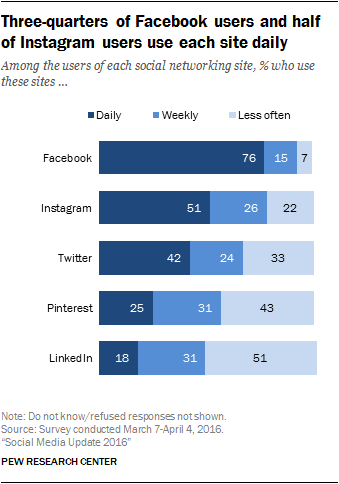Identify some key points in this picture. The ratio of the medians of the navy blue and light blue bars is 1.61538... According to a recent study, approximately 18% of LinkedIn users use the platform on a daily basis. 